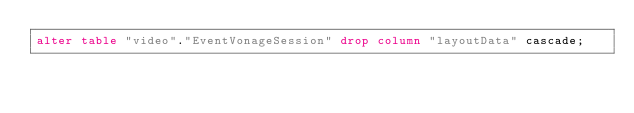Convert code to text. <code><loc_0><loc_0><loc_500><loc_500><_SQL_>alter table "video"."EventVonageSession" drop column "layoutData" cascade;
</code> 